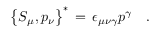<formula> <loc_0><loc_0><loc_500><loc_500>\left \{ S _ { \mu } , p _ { \nu } \right \} ^ { \ast } \, = \, \epsilon _ { \mu \nu \gamma } p ^ { \gamma } \quad .</formula> 